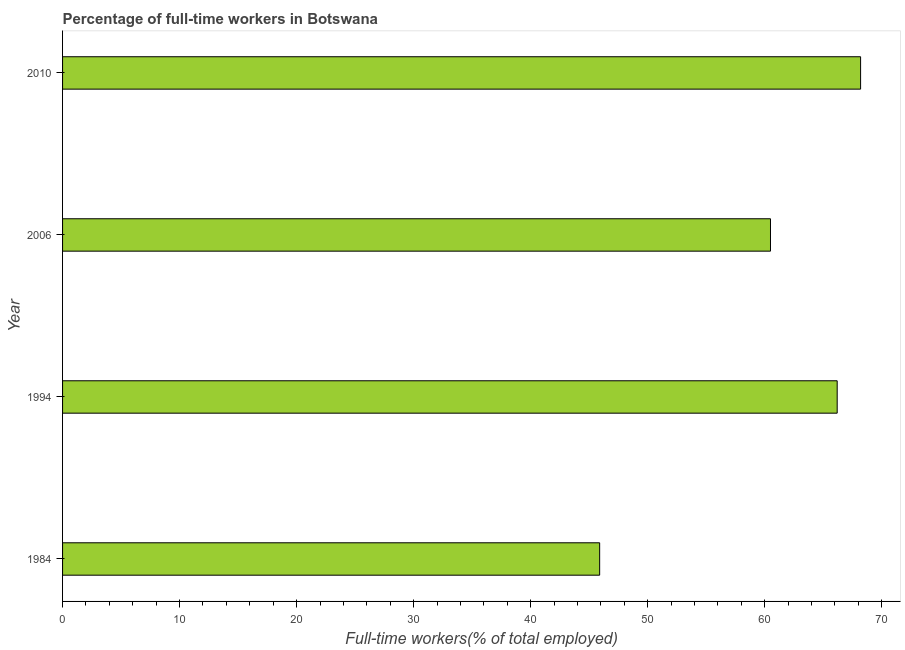What is the title of the graph?
Offer a very short reply. Percentage of full-time workers in Botswana. What is the label or title of the X-axis?
Your response must be concise. Full-time workers(% of total employed). What is the label or title of the Y-axis?
Your response must be concise. Year. What is the percentage of full-time workers in 1984?
Provide a succinct answer. 45.9. Across all years, what is the maximum percentage of full-time workers?
Keep it short and to the point. 68.2. Across all years, what is the minimum percentage of full-time workers?
Offer a terse response. 45.9. In which year was the percentage of full-time workers minimum?
Your response must be concise. 1984. What is the sum of the percentage of full-time workers?
Your answer should be compact. 240.8. What is the difference between the percentage of full-time workers in 1984 and 2006?
Your answer should be compact. -14.6. What is the average percentage of full-time workers per year?
Keep it short and to the point. 60.2. What is the median percentage of full-time workers?
Your answer should be very brief. 63.35. Do a majority of the years between 1984 and 2010 (inclusive) have percentage of full-time workers greater than 50 %?
Your answer should be compact. Yes. What is the ratio of the percentage of full-time workers in 2006 to that in 2010?
Ensure brevity in your answer.  0.89. Is the percentage of full-time workers in 1984 less than that in 2006?
Give a very brief answer. Yes. Is the difference between the percentage of full-time workers in 1994 and 2006 greater than the difference between any two years?
Keep it short and to the point. No. What is the difference between the highest and the second highest percentage of full-time workers?
Make the answer very short. 2. What is the difference between the highest and the lowest percentage of full-time workers?
Make the answer very short. 22.3. In how many years, is the percentage of full-time workers greater than the average percentage of full-time workers taken over all years?
Provide a short and direct response. 3. Are all the bars in the graph horizontal?
Ensure brevity in your answer.  Yes. Are the values on the major ticks of X-axis written in scientific E-notation?
Give a very brief answer. No. What is the Full-time workers(% of total employed) in 1984?
Your answer should be very brief. 45.9. What is the Full-time workers(% of total employed) in 1994?
Offer a terse response. 66.2. What is the Full-time workers(% of total employed) of 2006?
Your answer should be very brief. 60.5. What is the Full-time workers(% of total employed) in 2010?
Your answer should be very brief. 68.2. What is the difference between the Full-time workers(% of total employed) in 1984 and 1994?
Offer a terse response. -20.3. What is the difference between the Full-time workers(% of total employed) in 1984 and 2006?
Give a very brief answer. -14.6. What is the difference between the Full-time workers(% of total employed) in 1984 and 2010?
Offer a terse response. -22.3. What is the difference between the Full-time workers(% of total employed) in 1994 and 2006?
Provide a short and direct response. 5.7. What is the difference between the Full-time workers(% of total employed) in 2006 and 2010?
Offer a very short reply. -7.7. What is the ratio of the Full-time workers(% of total employed) in 1984 to that in 1994?
Provide a short and direct response. 0.69. What is the ratio of the Full-time workers(% of total employed) in 1984 to that in 2006?
Your response must be concise. 0.76. What is the ratio of the Full-time workers(% of total employed) in 1984 to that in 2010?
Offer a very short reply. 0.67. What is the ratio of the Full-time workers(% of total employed) in 1994 to that in 2006?
Keep it short and to the point. 1.09. What is the ratio of the Full-time workers(% of total employed) in 1994 to that in 2010?
Provide a short and direct response. 0.97. What is the ratio of the Full-time workers(% of total employed) in 2006 to that in 2010?
Make the answer very short. 0.89. 